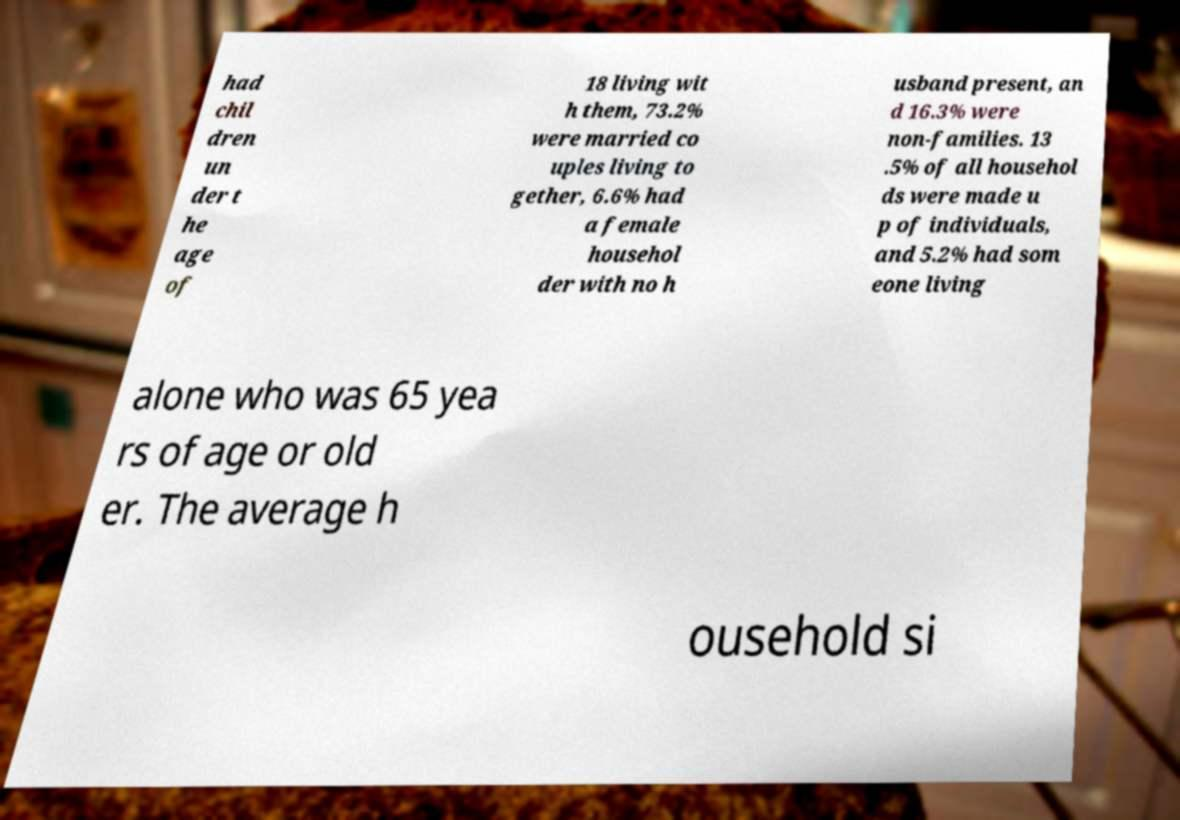Could you assist in decoding the text presented in this image and type it out clearly? had chil dren un der t he age of 18 living wit h them, 73.2% were married co uples living to gether, 6.6% had a female househol der with no h usband present, an d 16.3% were non-families. 13 .5% of all househol ds were made u p of individuals, and 5.2% had som eone living alone who was 65 yea rs of age or old er. The average h ousehold si 